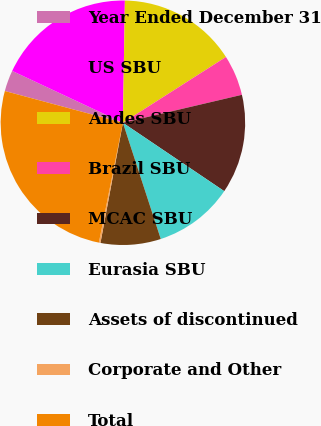Convert chart to OTSL. <chart><loc_0><loc_0><loc_500><loc_500><pie_chart><fcel>Year Ended December 31<fcel>US SBU<fcel>Andes SBU<fcel>Brazil SBU<fcel>MCAC SBU<fcel>Eurasia SBU<fcel>Assets of discontinued<fcel>Corporate and Other<fcel>Total<nl><fcel>2.79%<fcel>18.29%<fcel>15.7%<fcel>5.37%<fcel>13.12%<fcel>10.54%<fcel>7.95%<fcel>0.21%<fcel>26.03%<nl></chart> 